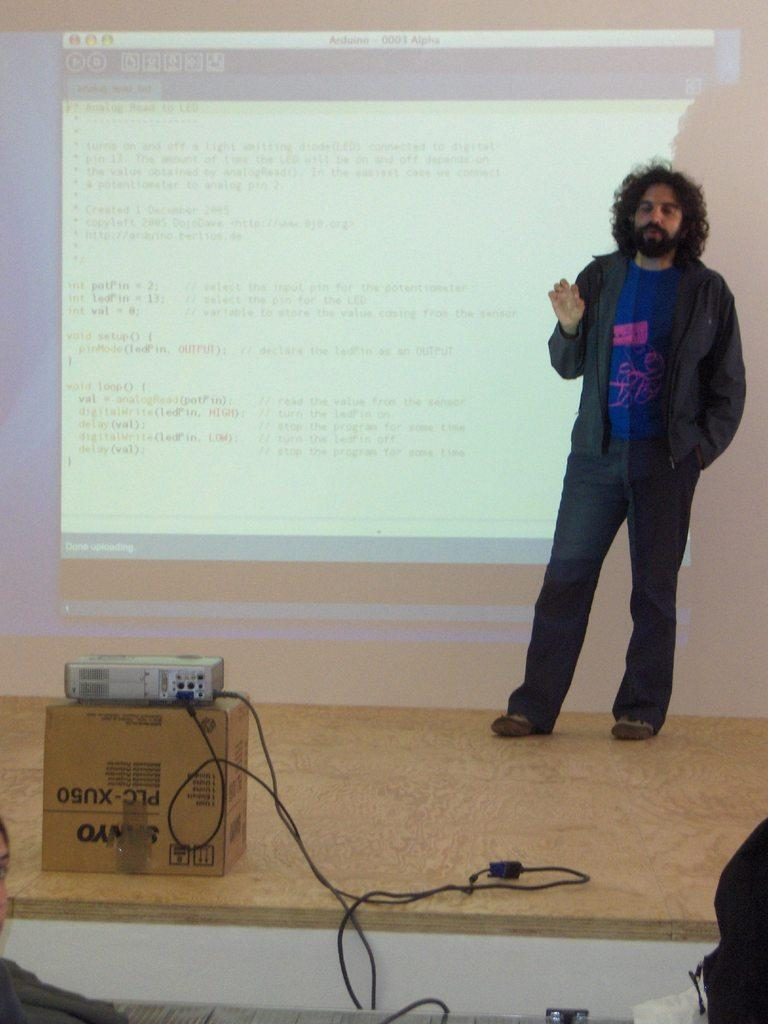What is the man doing in the image? The man is standing on stage. What can be seen on the wall behind the man? There is a screen on the wall. What device is in front of the man? There is a projector machine in front of the man. What country is the man visiting in the image? The image does not provide any information about the country the man is in. How many friends is the man with in the image? The image does not show any friends with the man; he is standing alone on stage. 